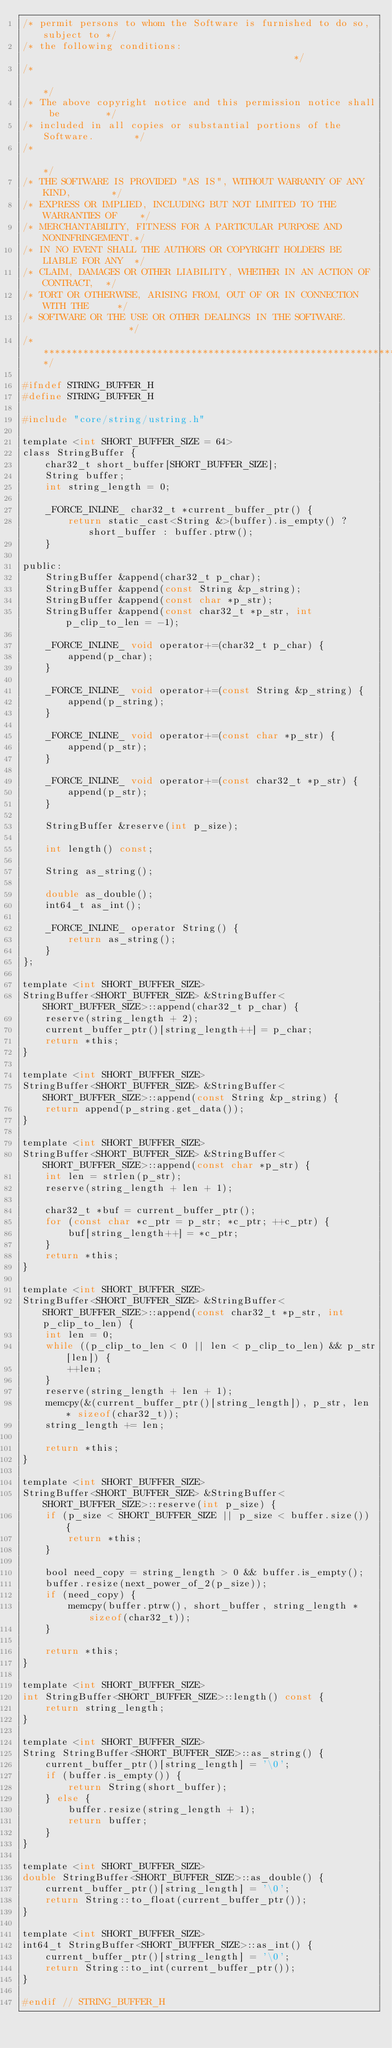<code> <loc_0><loc_0><loc_500><loc_500><_C_>/* permit persons to whom the Software is furnished to do so, subject to */
/* the following conditions:                                             */
/*                                                                       */
/* The above copyright notice and this permission notice shall be        */
/* included in all copies or substantial portions of the Software.       */
/*                                                                       */
/* THE SOFTWARE IS PROVIDED "AS IS", WITHOUT WARRANTY OF ANY KIND,       */
/* EXPRESS OR IMPLIED, INCLUDING BUT NOT LIMITED TO THE WARRANTIES OF    */
/* MERCHANTABILITY, FITNESS FOR A PARTICULAR PURPOSE AND NONINFRINGEMENT.*/
/* IN NO EVENT SHALL THE AUTHORS OR COPYRIGHT HOLDERS BE LIABLE FOR ANY  */
/* CLAIM, DAMAGES OR OTHER LIABILITY, WHETHER IN AN ACTION OF CONTRACT,  */
/* TORT OR OTHERWISE, ARISING FROM, OUT OF OR IN CONNECTION WITH THE     */
/* SOFTWARE OR THE USE OR OTHER DEALINGS IN THE SOFTWARE.                */
/*************************************************************************/

#ifndef STRING_BUFFER_H
#define STRING_BUFFER_H

#include "core/string/ustring.h"

template <int SHORT_BUFFER_SIZE = 64>
class StringBuffer {
	char32_t short_buffer[SHORT_BUFFER_SIZE];
	String buffer;
	int string_length = 0;

	_FORCE_INLINE_ char32_t *current_buffer_ptr() {
		return static_cast<String &>(buffer).is_empty() ? short_buffer : buffer.ptrw();
	}

public:
	StringBuffer &append(char32_t p_char);
	StringBuffer &append(const String &p_string);
	StringBuffer &append(const char *p_str);
	StringBuffer &append(const char32_t *p_str, int p_clip_to_len = -1);

	_FORCE_INLINE_ void operator+=(char32_t p_char) {
		append(p_char);
	}

	_FORCE_INLINE_ void operator+=(const String &p_string) {
		append(p_string);
	}

	_FORCE_INLINE_ void operator+=(const char *p_str) {
		append(p_str);
	}

	_FORCE_INLINE_ void operator+=(const char32_t *p_str) {
		append(p_str);
	}

	StringBuffer &reserve(int p_size);

	int length() const;

	String as_string();

	double as_double();
	int64_t as_int();

	_FORCE_INLINE_ operator String() {
		return as_string();
	}
};

template <int SHORT_BUFFER_SIZE>
StringBuffer<SHORT_BUFFER_SIZE> &StringBuffer<SHORT_BUFFER_SIZE>::append(char32_t p_char) {
	reserve(string_length + 2);
	current_buffer_ptr()[string_length++] = p_char;
	return *this;
}

template <int SHORT_BUFFER_SIZE>
StringBuffer<SHORT_BUFFER_SIZE> &StringBuffer<SHORT_BUFFER_SIZE>::append(const String &p_string) {
	return append(p_string.get_data());
}

template <int SHORT_BUFFER_SIZE>
StringBuffer<SHORT_BUFFER_SIZE> &StringBuffer<SHORT_BUFFER_SIZE>::append(const char *p_str) {
	int len = strlen(p_str);
	reserve(string_length + len + 1);

	char32_t *buf = current_buffer_ptr();
	for (const char *c_ptr = p_str; *c_ptr; ++c_ptr) {
		buf[string_length++] = *c_ptr;
	}
	return *this;
}

template <int SHORT_BUFFER_SIZE>
StringBuffer<SHORT_BUFFER_SIZE> &StringBuffer<SHORT_BUFFER_SIZE>::append(const char32_t *p_str, int p_clip_to_len) {
	int len = 0;
	while ((p_clip_to_len < 0 || len < p_clip_to_len) && p_str[len]) {
		++len;
	}
	reserve(string_length + len + 1);
	memcpy(&(current_buffer_ptr()[string_length]), p_str, len * sizeof(char32_t));
	string_length += len;

	return *this;
}

template <int SHORT_BUFFER_SIZE>
StringBuffer<SHORT_BUFFER_SIZE> &StringBuffer<SHORT_BUFFER_SIZE>::reserve(int p_size) {
	if (p_size < SHORT_BUFFER_SIZE || p_size < buffer.size()) {
		return *this;
	}

	bool need_copy = string_length > 0 && buffer.is_empty();
	buffer.resize(next_power_of_2(p_size));
	if (need_copy) {
		memcpy(buffer.ptrw(), short_buffer, string_length * sizeof(char32_t));
	}

	return *this;
}

template <int SHORT_BUFFER_SIZE>
int StringBuffer<SHORT_BUFFER_SIZE>::length() const {
	return string_length;
}

template <int SHORT_BUFFER_SIZE>
String StringBuffer<SHORT_BUFFER_SIZE>::as_string() {
	current_buffer_ptr()[string_length] = '\0';
	if (buffer.is_empty()) {
		return String(short_buffer);
	} else {
		buffer.resize(string_length + 1);
		return buffer;
	}
}

template <int SHORT_BUFFER_SIZE>
double StringBuffer<SHORT_BUFFER_SIZE>::as_double() {
	current_buffer_ptr()[string_length] = '\0';
	return String::to_float(current_buffer_ptr());
}

template <int SHORT_BUFFER_SIZE>
int64_t StringBuffer<SHORT_BUFFER_SIZE>::as_int() {
	current_buffer_ptr()[string_length] = '\0';
	return String::to_int(current_buffer_ptr());
}

#endif // STRING_BUFFER_H
</code> 